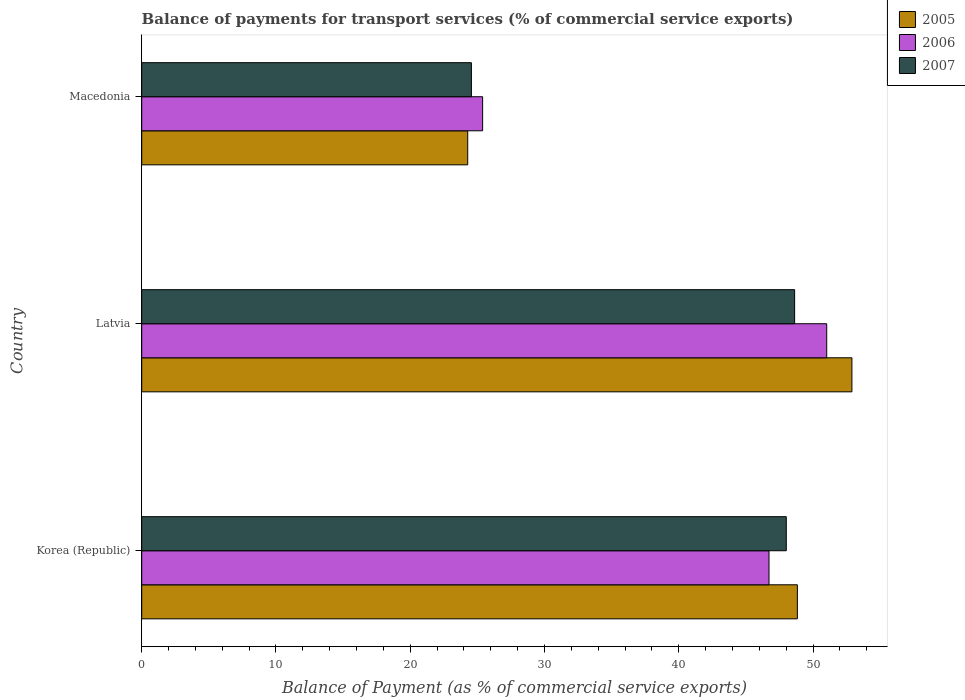How many different coloured bars are there?
Provide a short and direct response. 3. How many groups of bars are there?
Offer a terse response. 3. Are the number of bars per tick equal to the number of legend labels?
Your answer should be compact. Yes. Are the number of bars on each tick of the Y-axis equal?
Offer a terse response. Yes. How many bars are there on the 3rd tick from the bottom?
Your answer should be compact. 3. What is the label of the 1st group of bars from the top?
Provide a short and direct response. Macedonia. What is the balance of payments for transport services in 2006 in Latvia?
Give a very brief answer. 51.02. Across all countries, what is the maximum balance of payments for transport services in 2007?
Provide a succinct answer. 48.63. Across all countries, what is the minimum balance of payments for transport services in 2005?
Ensure brevity in your answer.  24.28. In which country was the balance of payments for transport services in 2006 maximum?
Offer a terse response. Latvia. In which country was the balance of payments for transport services in 2005 minimum?
Ensure brevity in your answer.  Macedonia. What is the total balance of payments for transport services in 2005 in the graph?
Make the answer very short. 126.02. What is the difference between the balance of payments for transport services in 2007 in Korea (Republic) and that in Macedonia?
Your response must be concise. 23.45. What is the difference between the balance of payments for transport services in 2006 in Macedonia and the balance of payments for transport services in 2007 in Latvia?
Keep it short and to the point. -23.24. What is the average balance of payments for transport services in 2006 per country?
Give a very brief answer. 41.05. What is the difference between the balance of payments for transport services in 2007 and balance of payments for transport services in 2006 in Korea (Republic)?
Keep it short and to the point. 1.29. In how many countries, is the balance of payments for transport services in 2007 greater than 12 %?
Offer a terse response. 3. What is the ratio of the balance of payments for transport services in 2006 in Latvia to that in Macedonia?
Your answer should be compact. 2.01. Is the difference between the balance of payments for transport services in 2007 in Korea (Republic) and Latvia greater than the difference between the balance of payments for transport services in 2006 in Korea (Republic) and Latvia?
Your answer should be compact. Yes. What is the difference between the highest and the second highest balance of payments for transport services in 2005?
Provide a succinct answer. 4.06. What is the difference between the highest and the lowest balance of payments for transport services in 2007?
Make the answer very short. 24.07. What does the 1st bar from the bottom in Korea (Republic) represents?
Give a very brief answer. 2005. Is it the case that in every country, the sum of the balance of payments for transport services in 2006 and balance of payments for transport services in 2007 is greater than the balance of payments for transport services in 2005?
Provide a short and direct response. Yes. How many bars are there?
Offer a terse response. 9. Are all the bars in the graph horizontal?
Offer a terse response. Yes. What is the difference between two consecutive major ticks on the X-axis?
Ensure brevity in your answer.  10. Are the values on the major ticks of X-axis written in scientific E-notation?
Provide a succinct answer. No. Does the graph contain any zero values?
Offer a very short reply. No. Does the graph contain grids?
Make the answer very short. No. How are the legend labels stacked?
Your answer should be very brief. Vertical. What is the title of the graph?
Offer a very short reply. Balance of payments for transport services (% of commercial service exports). What is the label or title of the X-axis?
Offer a very short reply. Balance of Payment (as % of commercial service exports). What is the Balance of Payment (as % of commercial service exports) in 2005 in Korea (Republic)?
Ensure brevity in your answer.  48.84. What is the Balance of Payment (as % of commercial service exports) of 2006 in Korea (Republic)?
Keep it short and to the point. 46.72. What is the Balance of Payment (as % of commercial service exports) in 2007 in Korea (Republic)?
Offer a terse response. 48.01. What is the Balance of Payment (as % of commercial service exports) in 2005 in Latvia?
Make the answer very short. 52.9. What is the Balance of Payment (as % of commercial service exports) of 2006 in Latvia?
Provide a succinct answer. 51.02. What is the Balance of Payment (as % of commercial service exports) in 2007 in Latvia?
Your answer should be compact. 48.63. What is the Balance of Payment (as % of commercial service exports) of 2005 in Macedonia?
Make the answer very short. 24.28. What is the Balance of Payment (as % of commercial service exports) in 2006 in Macedonia?
Your response must be concise. 25.39. What is the Balance of Payment (as % of commercial service exports) of 2007 in Macedonia?
Provide a succinct answer. 24.56. Across all countries, what is the maximum Balance of Payment (as % of commercial service exports) of 2005?
Offer a very short reply. 52.9. Across all countries, what is the maximum Balance of Payment (as % of commercial service exports) in 2006?
Your answer should be compact. 51.02. Across all countries, what is the maximum Balance of Payment (as % of commercial service exports) of 2007?
Ensure brevity in your answer.  48.63. Across all countries, what is the minimum Balance of Payment (as % of commercial service exports) of 2005?
Offer a terse response. 24.28. Across all countries, what is the minimum Balance of Payment (as % of commercial service exports) in 2006?
Your answer should be compact. 25.39. Across all countries, what is the minimum Balance of Payment (as % of commercial service exports) of 2007?
Keep it short and to the point. 24.56. What is the total Balance of Payment (as % of commercial service exports) in 2005 in the graph?
Offer a very short reply. 126.02. What is the total Balance of Payment (as % of commercial service exports) of 2006 in the graph?
Your answer should be very brief. 123.14. What is the total Balance of Payment (as % of commercial service exports) of 2007 in the graph?
Your answer should be very brief. 121.2. What is the difference between the Balance of Payment (as % of commercial service exports) of 2005 in Korea (Republic) and that in Latvia?
Offer a very short reply. -4.06. What is the difference between the Balance of Payment (as % of commercial service exports) of 2006 in Korea (Republic) and that in Latvia?
Offer a very short reply. -4.3. What is the difference between the Balance of Payment (as % of commercial service exports) of 2007 in Korea (Republic) and that in Latvia?
Keep it short and to the point. -0.62. What is the difference between the Balance of Payment (as % of commercial service exports) in 2005 in Korea (Republic) and that in Macedonia?
Offer a terse response. 24.55. What is the difference between the Balance of Payment (as % of commercial service exports) in 2006 in Korea (Republic) and that in Macedonia?
Your answer should be very brief. 21.33. What is the difference between the Balance of Payment (as % of commercial service exports) in 2007 in Korea (Republic) and that in Macedonia?
Offer a very short reply. 23.45. What is the difference between the Balance of Payment (as % of commercial service exports) in 2005 in Latvia and that in Macedonia?
Offer a terse response. 28.62. What is the difference between the Balance of Payment (as % of commercial service exports) of 2006 in Latvia and that in Macedonia?
Your answer should be very brief. 25.63. What is the difference between the Balance of Payment (as % of commercial service exports) of 2007 in Latvia and that in Macedonia?
Your answer should be compact. 24.07. What is the difference between the Balance of Payment (as % of commercial service exports) in 2005 in Korea (Republic) and the Balance of Payment (as % of commercial service exports) in 2006 in Latvia?
Provide a short and direct response. -2.19. What is the difference between the Balance of Payment (as % of commercial service exports) in 2005 in Korea (Republic) and the Balance of Payment (as % of commercial service exports) in 2007 in Latvia?
Keep it short and to the point. 0.2. What is the difference between the Balance of Payment (as % of commercial service exports) in 2006 in Korea (Republic) and the Balance of Payment (as % of commercial service exports) in 2007 in Latvia?
Offer a terse response. -1.91. What is the difference between the Balance of Payment (as % of commercial service exports) in 2005 in Korea (Republic) and the Balance of Payment (as % of commercial service exports) in 2006 in Macedonia?
Your answer should be compact. 23.44. What is the difference between the Balance of Payment (as % of commercial service exports) in 2005 in Korea (Republic) and the Balance of Payment (as % of commercial service exports) in 2007 in Macedonia?
Keep it short and to the point. 24.28. What is the difference between the Balance of Payment (as % of commercial service exports) in 2006 in Korea (Republic) and the Balance of Payment (as % of commercial service exports) in 2007 in Macedonia?
Offer a very short reply. 22.17. What is the difference between the Balance of Payment (as % of commercial service exports) of 2005 in Latvia and the Balance of Payment (as % of commercial service exports) of 2006 in Macedonia?
Provide a short and direct response. 27.51. What is the difference between the Balance of Payment (as % of commercial service exports) of 2005 in Latvia and the Balance of Payment (as % of commercial service exports) of 2007 in Macedonia?
Your answer should be very brief. 28.34. What is the difference between the Balance of Payment (as % of commercial service exports) in 2006 in Latvia and the Balance of Payment (as % of commercial service exports) in 2007 in Macedonia?
Your answer should be very brief. 26.47. What is the average Balance of Payment (as % of commercial service exports) in 2005 per country?
Offer a very short reply. 42.01. What is the average Balance of Payment (as % of commercial service exports) of 2006 per country?
Offer a very short reply. 41.05. What is the average Balance of Payment (as % of commercial service exports) of 2007 per country?
Provide a succinct answer. 40.4. What is the difference between the Balance of Payment (as % of commercial service exports) in 2005 and Balance of Payment (as % of commercial service exports) in 2006 in Korea (Republic)?
Your answer should be very brief. 2.11. What is the difference between the Balance of Payment (as % of commercial service exports) in 2005 and Balance of Payment (as % of commercial service exports) in 2007 in Korea (Republic)?
Keep it short and to the point. 0.83. What is the difference between the Balance of Payment (as % of commercial service exports) in 2006 and Balance of Payment (as % of commercial service exports) in 2007 in Korea (Republic)?
Give a very brief answer. -1.29. What is the difference between the Balance of Payment (as % of commercial service exports) in 2005 and Balance of Payment (as % of commercial service exports) in 2006 in Latvia?
Your answer should be very brief. 1.88. What is the difference between the Balance of Payment (as % of commercial service exports) in 2005 and Balance of Payment (as % of commercial service exports) in 2007 in Latvia?
Offer a terse response. 4.27. What is the difference between the Balance of Payment (as % of commercial service exports) in 2006 and Balance of Payment (as % of commercial service exports) in 2007 in Latvia?
Your answer should be compact. 2.39. What is the difference between the Balance of Payment (as % of commercial service exports) of 2005 and Balance of Payment (as % of commercial service exports) of 2006 in Macedonia?
Ensure brevity in your answer.  -1.11. What is the difference between the Balance of Payment (as % of commercial service exports) of 2005 and Balance of Payment (as % of commercial service exports) of 2007 in Macedonia?
Give a very brief answer. -0.28. What is the difference between the Balance of Payment (as % of commercial service exports) in 2006 and Balance of Payment (as % of commercial service exports) in 2007 in Macedonia?
Make the answer very short. 0.84. What is the ratio of the Balance of Payment (as % of commercial service exports) in 2005 in Korea (Republic) to that in Latvia?
Provide a succinct answer. 0.92. What is the ratio of the Balance of Payment (as % of commercial service exports) in 2006 in Korea (Republic) to that in Latvia?
Provide a short and direct response. 0.92. What is the ratio of the Balance of Payment (as % of commercial service exports) of 2007 in Korea (Republic) to that in Latvia?
Provide a succinct answer. 0.99. What is the ratio of the Balance of Payment (as % of commercial service exports) in 2005 in Korea (Republic) to that in Macedonia?
Keep it short and to the point. 2.01. What is the ratio of the Balance of Payment (as % of commercial service exports) in 2006 in Korea (Republic) to that in Macedonia?
Ensure brevity in your answer.  1.84. What is the ratio of the Balance of Payment (as % of commercial service exports) in 2007 in Korea (Republic) to that in Macedonia?
Your answer should be compact. 1.96. What is the ratio of the Balance of Payment (as % of commercial service exports) in 2005 in Latvia to that in Macedonia?
Offer a terse response. 2.18. What is the ratio of the Balance of Payment (as % of commercial service exports) in 2006 in Latvia to that in Macedonia?
Provide a short and direct response. 2.01. What is the ratio of the Balance of Payment (as % of commercial service exports) in 2007 in Latvia to that in Macedonia?
Your answer should be compact. 1.98. What is the difference between the highest and the second highest Balance of Payment (as % of commercial service exports) in 2005?
Offer a very short reply. 4.06. What is the difference between the highest and the second highest Balance of Payment (as % of commercial service exports) in 2006?
Your response must be concise. 4.3. What is the difference between the highest and the second highest Balance of Payment (as % of commercial service exports) in 2007?
Provide a succinct answer. 0.62. What is the difference between the highest and the lowest Balance of Payment (as % of commercial service exports) of 2005?
Provide a succinct answer. 28.62. What is the difference between the highest and the lowest Balance of Payment (as % of commercial service exports) of 2006?
Keep it short and to the point. 25.63. What is the difference between the highest and the lowest Balance of Payment (as % of commercial service exports) in 2007?
Provide a succinct answer. 24.07. 